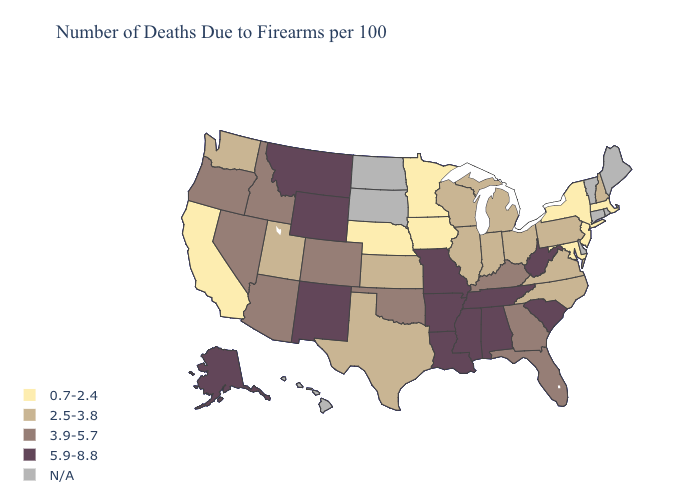What is the highest value in states that border New York?
Be succinct. 2.5-3.8. Which states have the lowest value in the USA?
Be succinct. California, Iowa, Maryland, Massachusetts, Minnesota, Nebraska, New Jersey, New York. Does the map have missing data?
Give a very brief answer. Yes. What is the value of Michigan?
Answer briefly. 2.5-3.8. What is the value of Delaware?
Answer briefly. N/A. What is the lowest value in the West?
Answer briefly. 0.7-2.4. Does the map have missing data?
Short answer required. Yes. What is the value of Delaware?
Keep it brief. N/A. Does Pennsylvania have the lowest value in the USA?
Be succinct. No. Does Arkansas have the highest value in the USA?
Short answer required. Yes. What is the value of Idaho?
Concise answer only. 3.9-5.7. What is the value of South Dakota?
Write a very short answer. N/A. 